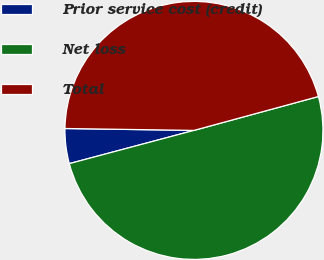<chart> <loc_0><loc_0><loc_500><loc_500><pie_chart><fcel>Prior service cost (credit)<fcel>Net loss<fcel>Total<nl><fcel>4.38%<fcel>50.08%<fcel>45.53%<nl></chart> 